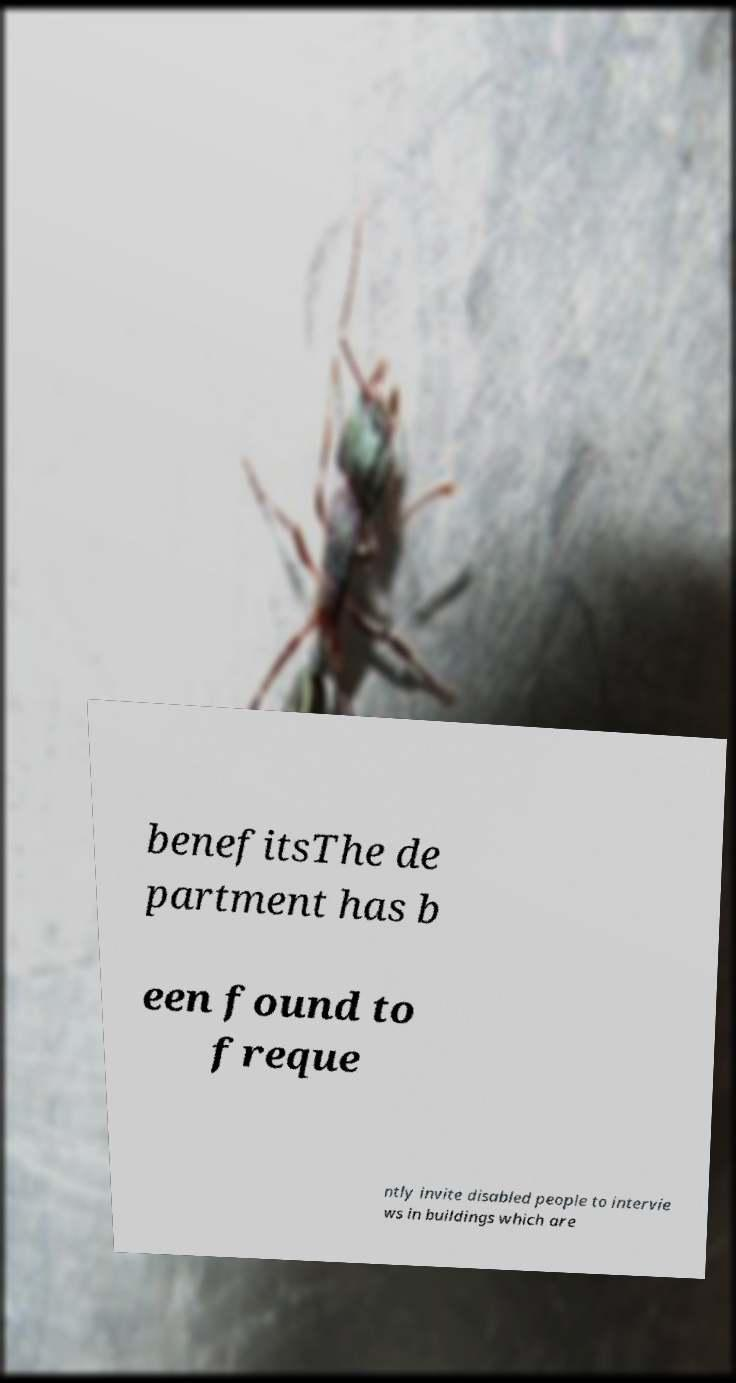There's text embedded in this image that I need extracted. Can you transcribe it verbatim? benefitsThe de partment has b een found to freque ntly invite disabled people to intervie ws in buildings which are 